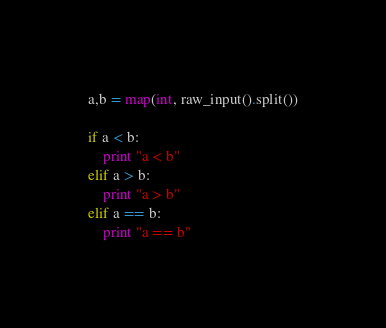<code> <loc_0><loc_0><loc_500><loc_500><_Python_>a,b = map(int, raw_input().split())

if a < b:
    print "a < b"
elif a > b:
    print "a > b"
elif a == b:
    print "a == b"</code> 